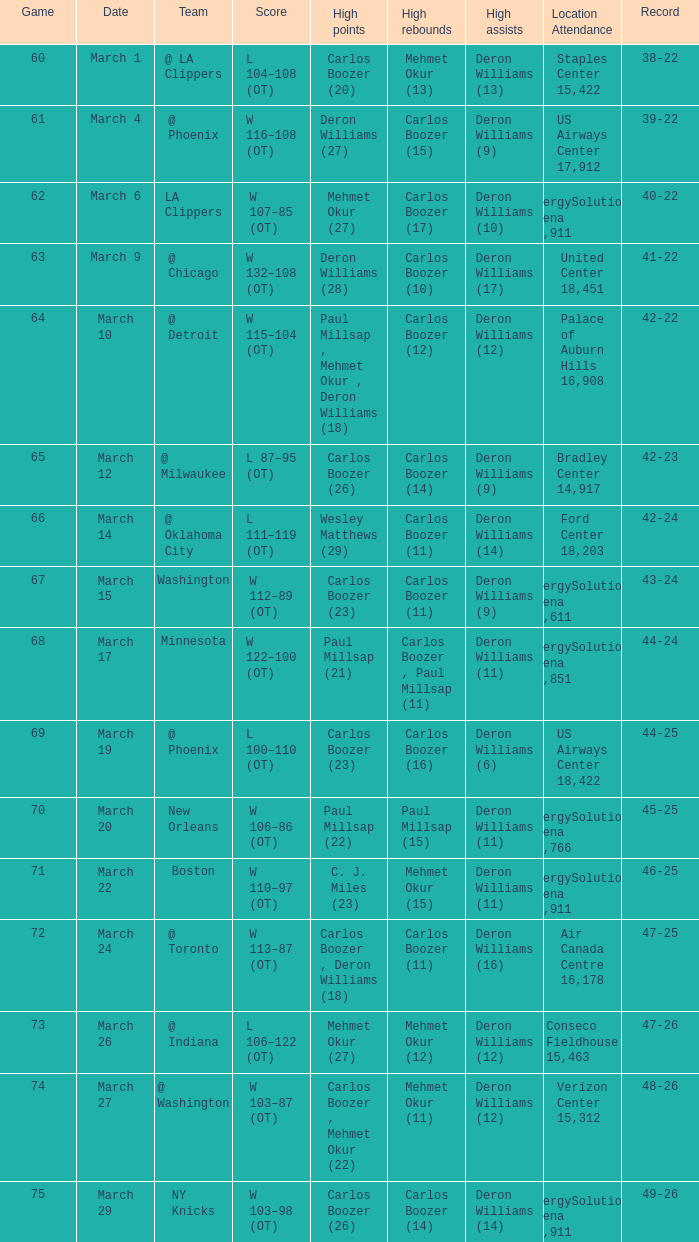Where was the game on march 24 held? Air Canada Centre 16,178. 